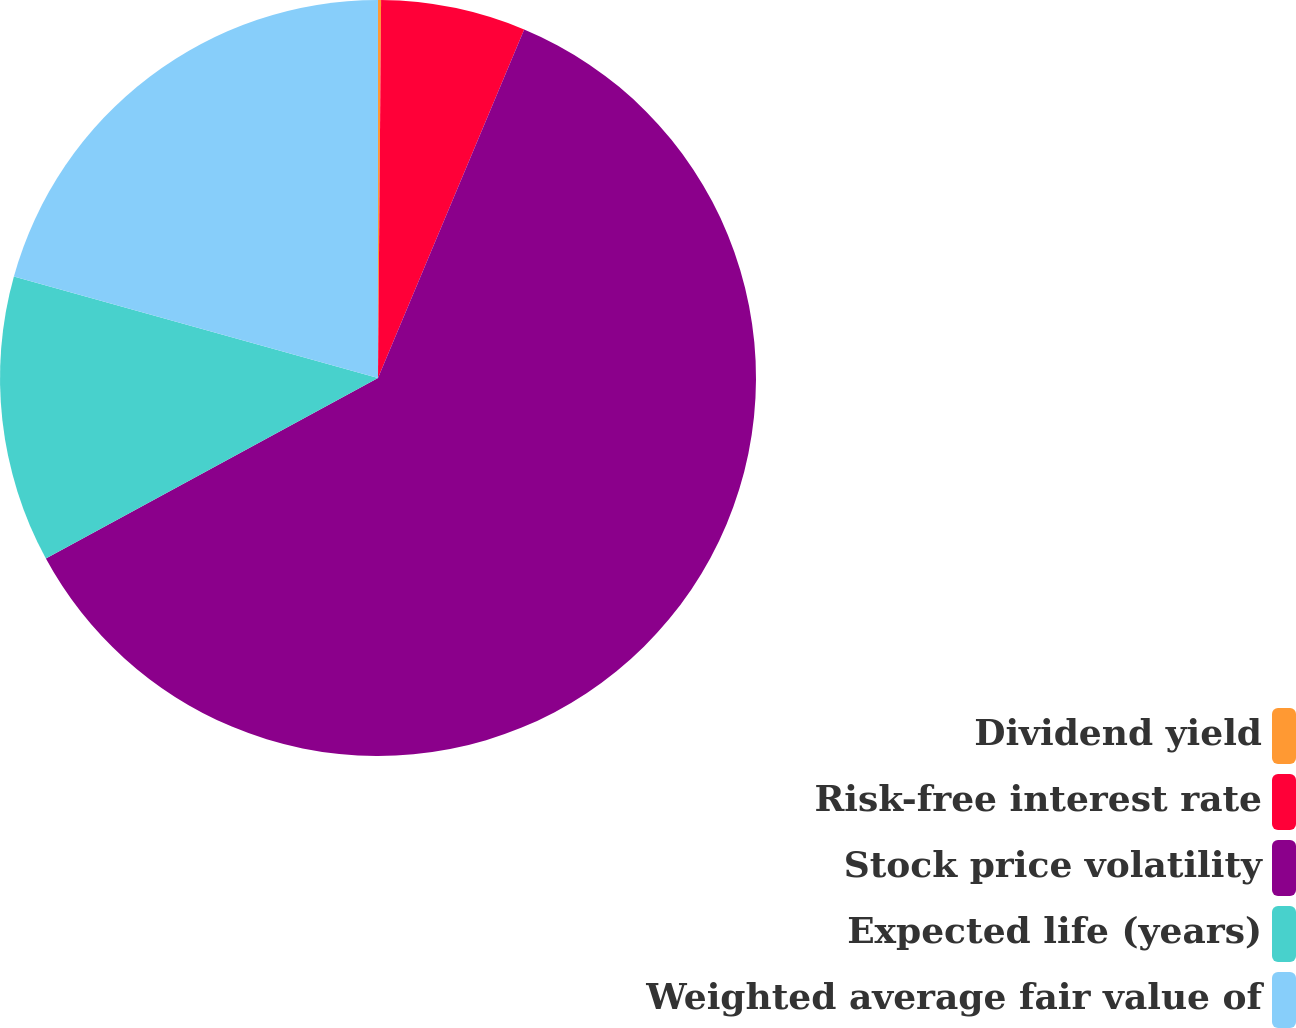<chart> <loc_0><loc_0><loc_500><loc_500><pie_chart><fcel>Dividend yield<fcel>Risk-free interest rate<fcel>Stock price volatility<fcel>Expected life (years)<fcel>Weighted average fair value of<nl><fcel>0.13%<fcel>6.19%<fcel>60.75%<fcel>12.25%<fcel>20.67%<nl></chart> 